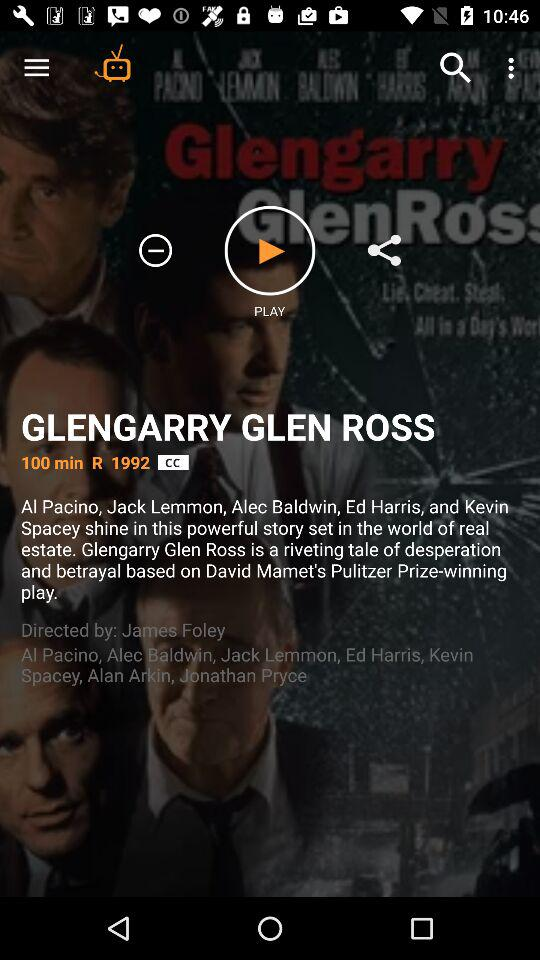What is the title of the show? The title of the show is "GLENGARRY GLEN ROSS". 